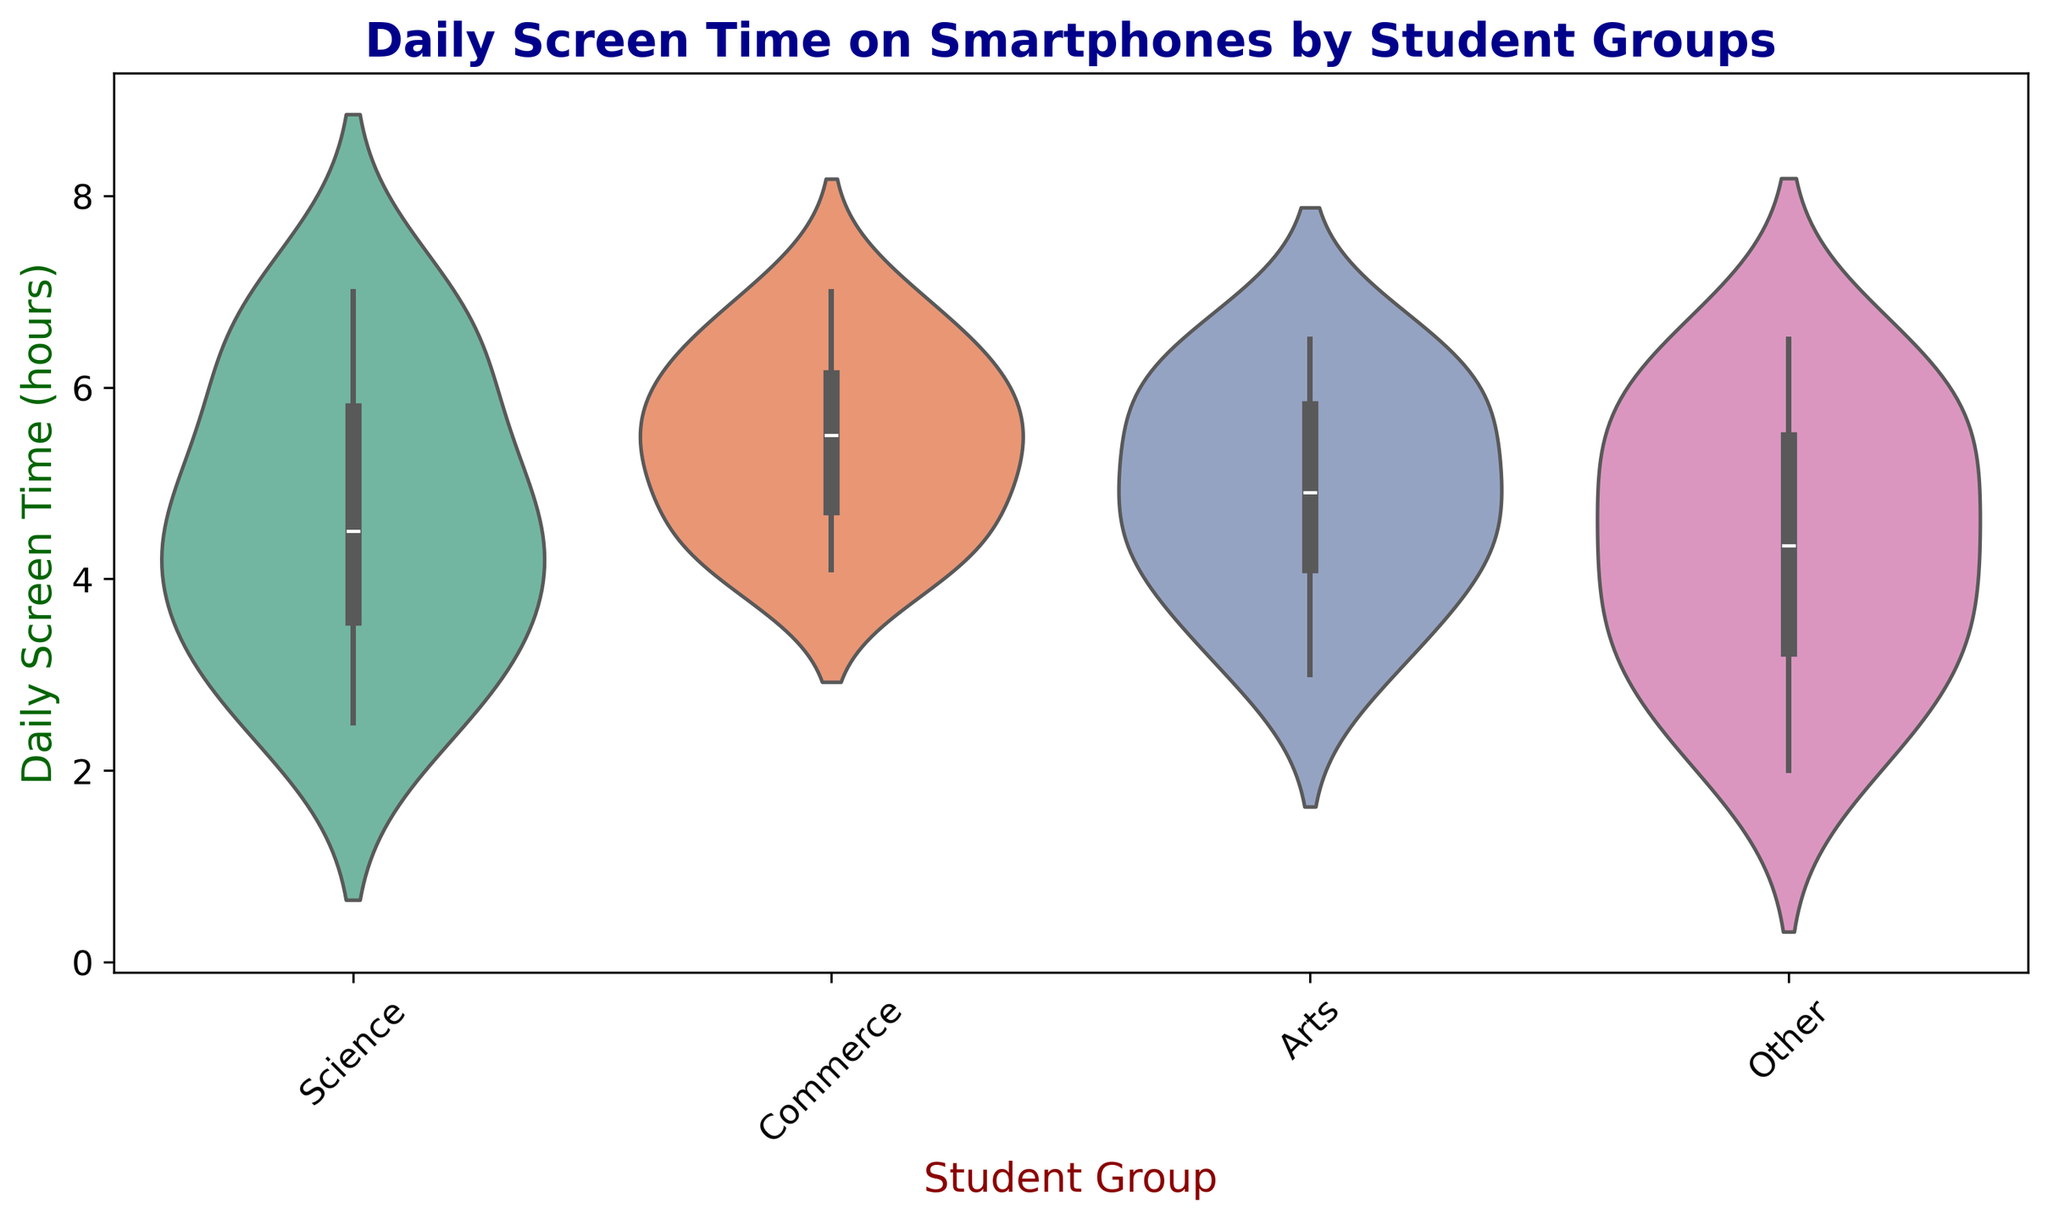Which student group has the highest median daily screen time? To find the highest median daily screen time, look at the centerlines of the vioplot distributions for each group. The thickest part of the violin plot indicates the median time. You can observe that the Commerce group has the highest median daily screen time.
Answer: Commerce Compare the range of daily screen time for Science and Arts students. Which group has a wider range? Examine the length of the violin plots for both groups. The longer the plot, the wider the range of data. The Science group has a range from around 2.5 to 7.0 hours, while Arts ranges from around 3.0 to 6.5 hours. Therefore, Science has a wider range.
Answer: Science What is the interquartile range (IQR) for the Commerce group? The IQR can be observed from violin plots where the densest areas between the first quartile and third quartile are visible. For Commerce, the densest region extends roughly from 4.5 to 6.2 hours. The IQR is 6.2 - 4.5 = 1.7 hours.
Answer: 1.7 hours Which student group shows the most variation in daily screen time? Variation is represented by the spread and shape of the violin plots. The Science plot spreads widely and smoothly from about 2.5 to 7.0 hours. Other groups have less spread. Therefore, Science has the most variation.
Answer: Science Is there any group where students have as low as 2 hours of daily screen time? Look at the lower bound of each violin plot. Only the "Other" group extends down to 2 hours of daily screen time.
Answer: Other Between Arts and Other students, which group has a more concentrated daily screen time around their median? Judge the concentration by looking at the peaks and narrowness around the median of each violin plot. The Art group's violin plot shows higher concentration around the median as it narrows sharply around the center compared to Others.
Answer: Arts What is the approximate maximum daily screen time recorded for the Science group? The top end of the Science group's violin plot denotes the maximum value. This point visually appears to be approximately 7.0 hours.
Answer: 7.0 hours Which student group is likely to have the least lower quartile daily screen time? The lower quartile can be estimated from the bottom section of each violin plot. The "Other" group appears to have the lowest lower quartile, around 3.0 hours.
Answer: Other Compare the upper whiskers of the violin plots for all groups, which group has the highest upper whisker? The upper whisker is indicated by the top end of each violin plot. Commerce group seems to have an upper whisker extending to around 7.0 hours, making it the highest.
Answer: Commerce 